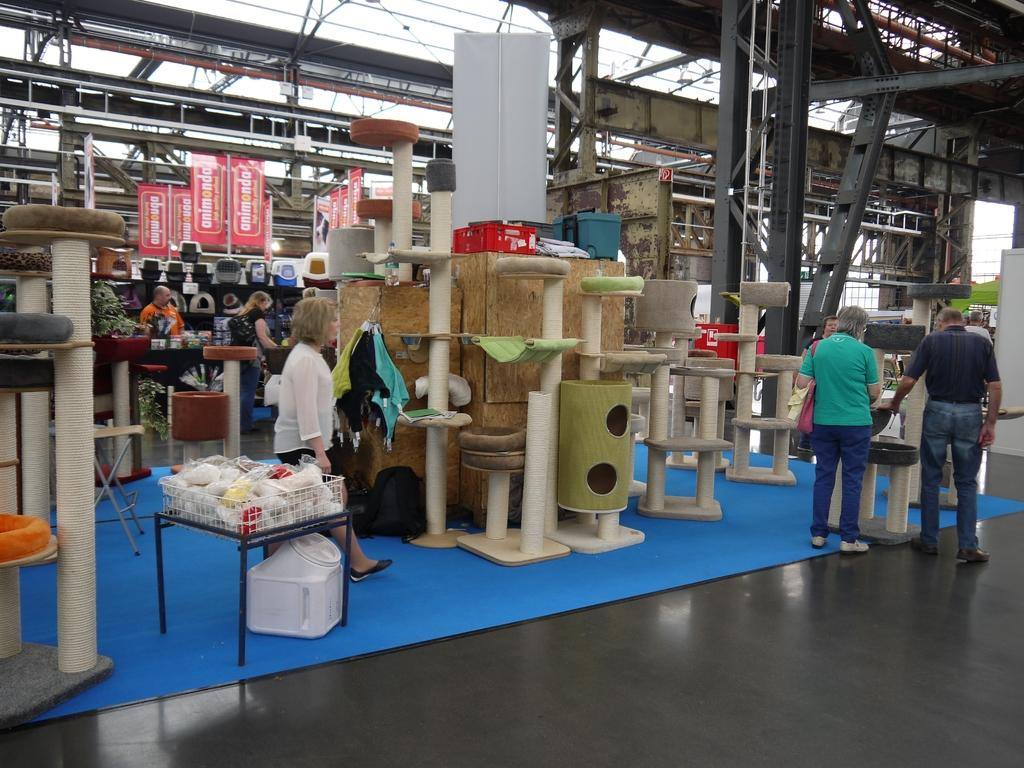What is happening in the image? There are people standing in the image, which appears to depict a shop. Can you describe any objects or items in the shop? There are objects placed on the floor in the image. What is hanging from the roof in the image? Banners are hanging from the roof in the image. What type of structural support can be seen in the image? Iron pillars are present in the image. Can you see any cracks in the image? There are no cracks visible in the image. Is there a railway visible in the image? There is no railway present in the image. Are there any geese in the image? There are no geese present in the image. 